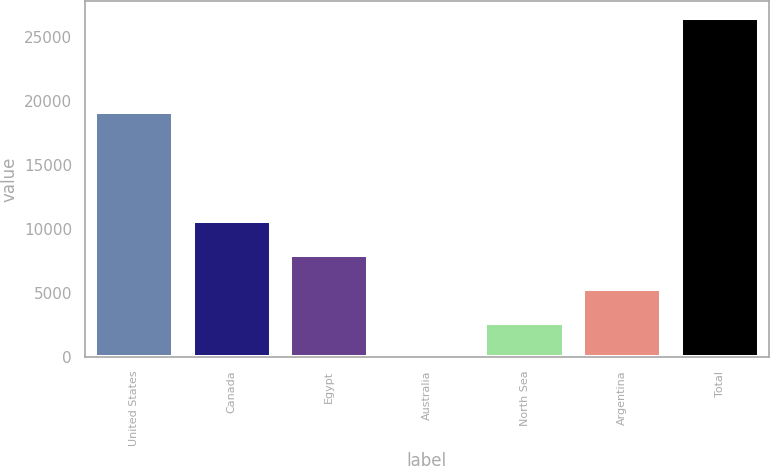Convert chart. <chart><loc_0><loc_0><loc_500><loc_500><bar_chart><fcel>United States<fcel>Canada<fcel>Egypt<fcel>Australia<fcel>North Sea<fcel>Argentina<fcel>Total<nl><fcel>19165<fcel>10627<fcel>7986.5<fcel>65<fcel>2705.5<fcel>5346<fcel>26470<nl></chart> 